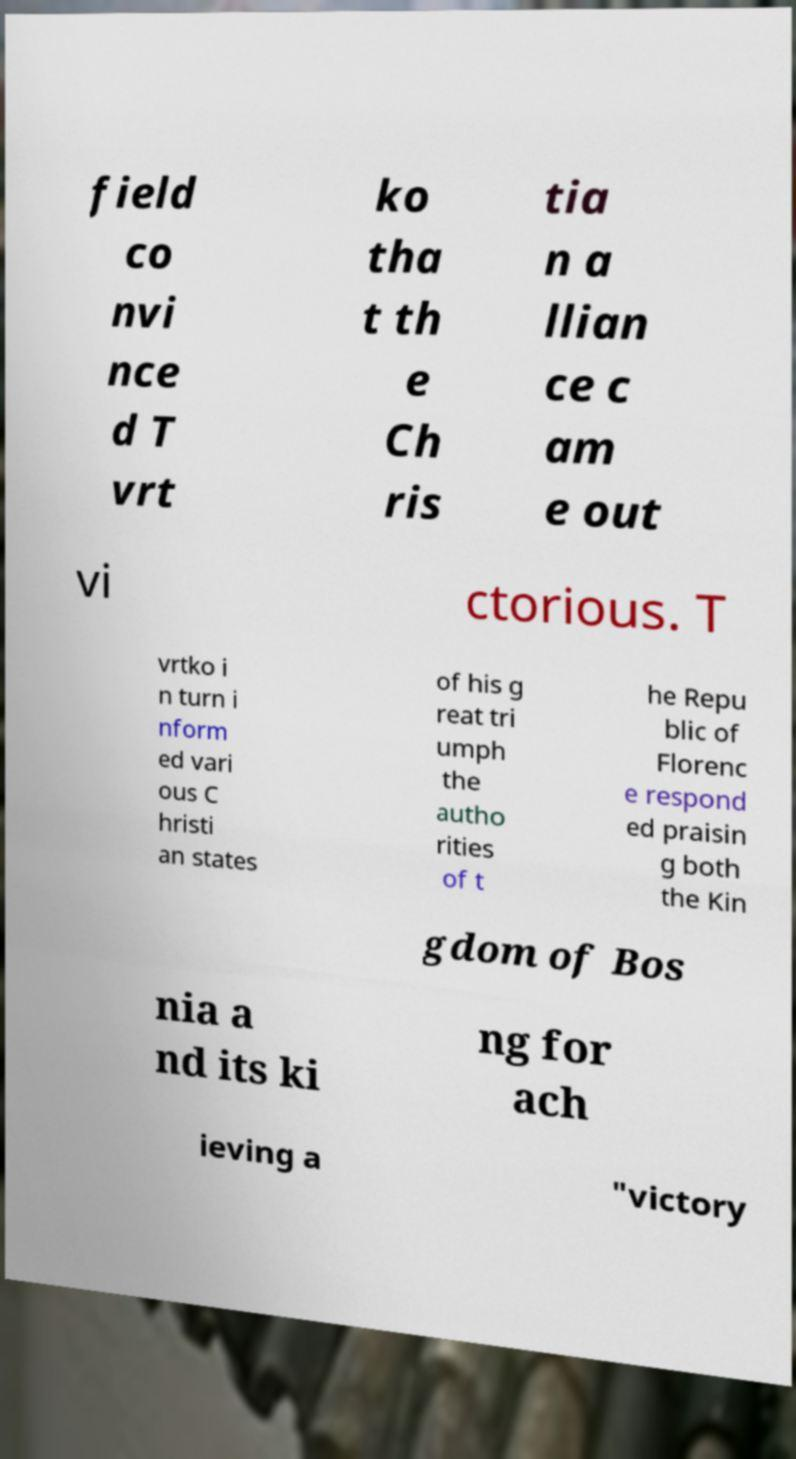Can you read and provide the text displayed in the image?This photo seems to have some interesting text. Can you extract and type it out for me? field co nvi nce d T vrt ko tha t th e Ch ris tia n a llian ce c am e out vi ctorious. T vrtko i n turn i nform ed vari ous C hristi an states of his g reat tri umph the autho rities of t he Repu blic of Florenc e respond ed praisin g both the Kin gdom of Bos nia a nd its ki ng for ach ieving a "victory 